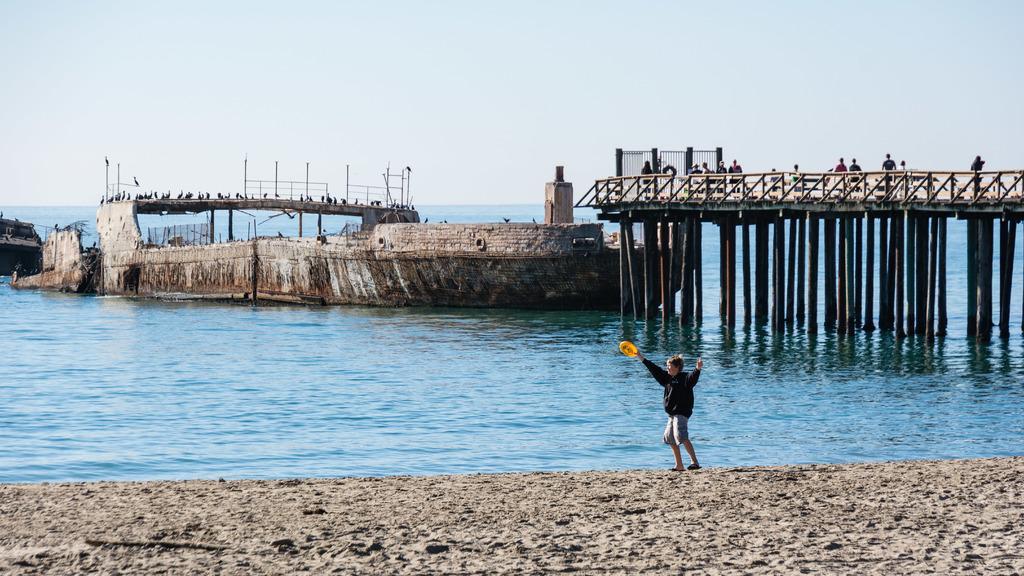How would you summarize this image in a sentence or two? In this image I can see few people,bridgewater,few birds,poles and grey color object. The sky is in blue and white color. 